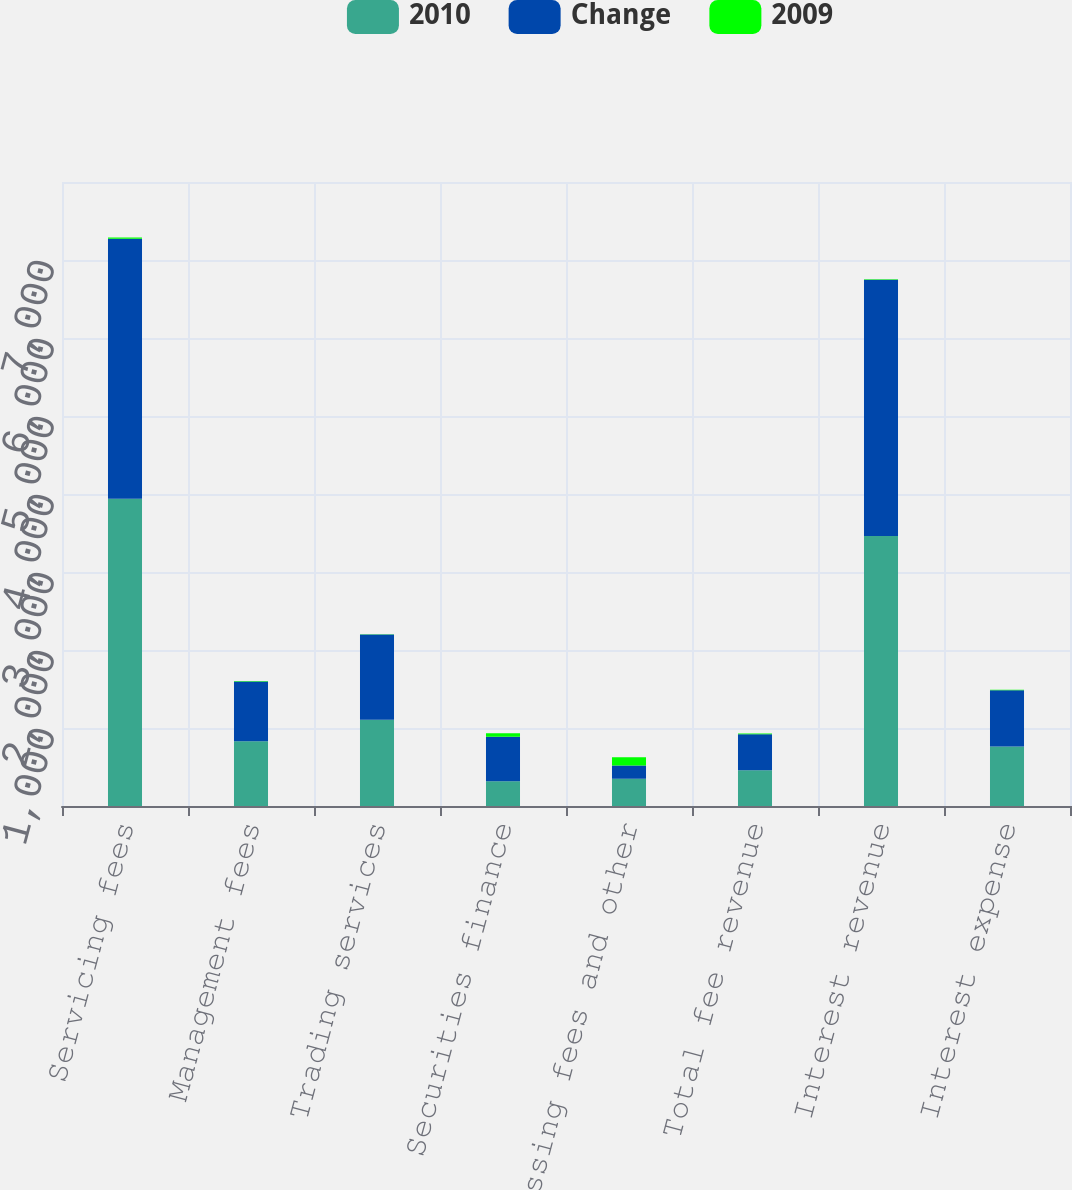Convert chart to OTSL. <chart><loc_0><loc_0><loc_500><loc_500><stacked_bar_chart><ecel><fcel>Servicing fees<fcel>Management fees<fcel>Trading services<fcel>Securities finance<fcel>Processing fees and other<fcel>Total fee revenue<fcel>Interest revenue<fcel>Interest expense<nl><fcel>2010<fcel>3938<fcel>829<fcel>1106<fcel>318<fcel>349<fcel>459.5<fcel>3462<fcel>763<nl><fcel>Change<fcel>3334<fcel>766<fcel>1094<fcel>570<fcel>171<fcel>459.5<fcel>3286<fcel>722<nl><fcel>2009<fcel>18<fcel>8<fcel>1<fcel>44<fcel>104<fcel>10<fcel>5<fcel>6<nl></chart> 